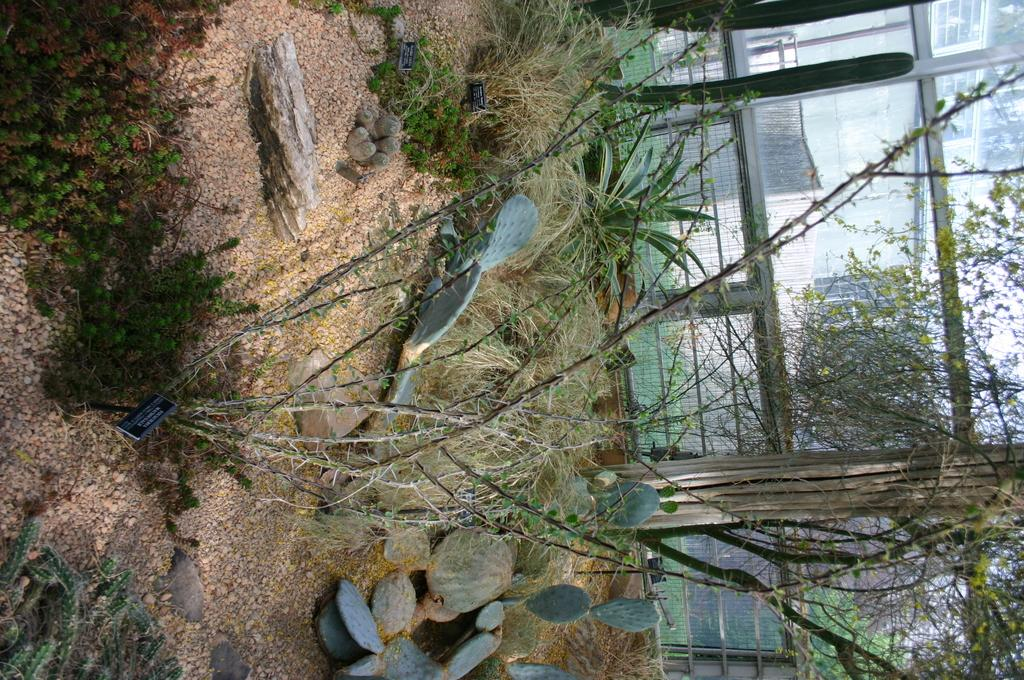What type of terrain is visible in the image? There is sand in the image. What other natural elements can be seen in the image? There are plants and rocks visible in the image. Are there any man-made structures in the image? Yes, there is railing visible in the background of the image. What is located near the railing in the background of the image? There are plants near the railing in the background of the image. What type of chin can be seen on the judge in the image? There is no judge or chin present in the image. What type of crow is visible in the image? There is no crow present in the image. 